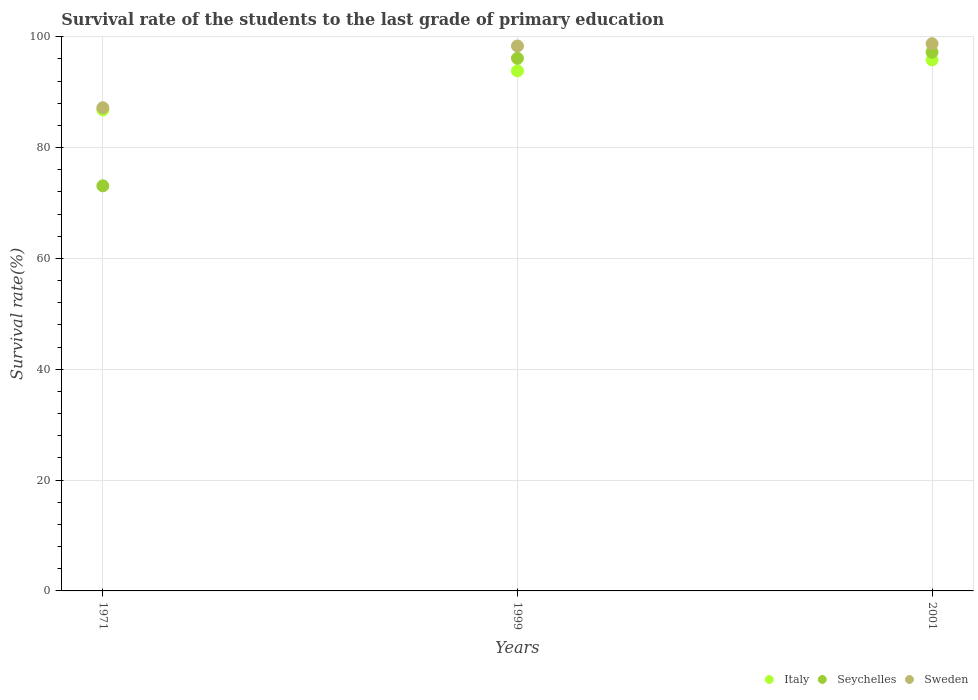What is the survival rate of the students in Italy in 1999?
Make the answer very short. 93.85. Across all years, what is the maximum survival rate of the students in Seychelles?
Make the answer very short. 97.21. Across all years, what is the minimum survival rate of the students in Seychelles?
Ensure brevity in your answer.  73.1. In which year was the survival rate of the students in Italy maximum?
Your response must be concise. 2001. In which year was the survival rate of the students in Seychelles minimum?
Make the answer very short. 1971. What is the total survival rate of the students in Seychelles in the graph?
Your answer should be very brief. 266.41. What is the difference between the survival rate of the students in Italy in 1971 and that in 1999?
Your answer should be compact. -7.06. What is the difference between the survival rate of the students in Italy in 1971 and the survival rate of the students in Seychelles in 1999?
Your answer should be compact. -9.32. What is the average survival rate of the students in Italy per year?
Provide a succinct answer. 92.15. In the year 1999, what is the difference between the survival rate of the students in Seychelles and survival rate of the students in Sweden?
Give a very brief answer. -2.23. In how many years, is the survival rate of the students in Sweden greater than 8 %?
Provide a succinct answer. 3. What is the ratio of the survival rate of the students in Sweden in 1971 to that in 1999?
Offer a terse response. 0.89. Is the survival rate of the students in Sweden in 1999 less than that in 2001?
Provide a succinct answer. Yes. What is the difference between the highest and the second highest survival rate of the students in Italy?
Your answer should be compact. 1.97. What is the difference between the highest and the lowest survival rate of the students in Sweden?
Ensure brevity in your answer.  11.56. In how many years, is the survival rate of the students in Italy greater than the average survival rate of the students in Italy taken over all years?
Provide a succinct answer. 2. Is the survival rate of the students in Sweden strictly greater than the survival rate of the students in Seychelles over the years?
Your answer should be very brief. Yes. Is the survival rate of the students in Italy strictly less than the survival rate of the students in Sweden over the years?
Provide a succinct answer. Yes. How many dotlines are there?
Offer a very short reply. 3. What is the difference between two consecutive major ticks on the Y-axis?
Your answer should be very brief. 20. How are the legend labels stacked?
Provide a short and direct response. Horizontal. What is the title of the graph?
Ensure brevity in your answer.  Survival rate of the students to the last grade of primary education. Does "Burundi" appear as one of the legend labels in the graph?
Your answer should be very brief. No. What is the label or title of the X-axis?
Provide a succinct answer. Years. What is the label or title of the Y-axis?
Your answer should be compact. Survival rate(%). What is the Survival rate(%) in Italy in 1971?
Make the answer very short. 86.79. What is the Survival rate(%) in Seychelles in 1971?
Give a very brief answer. 73.1. What is the Survival rate(%) in Sweden in 1971?
Make the answer very short. 87.19. What is the Survival rate(%) of Italy in 1999?
Keep it short and to the point. 93.85. What is the Survival rate(%) in Seychelles in 1999?
Your answer should be compact. 96.1. What is the Survival rate(%) of Sweden in 1999?
Your response must be concise. 98.33. What is the Survival rate(%) of Italy in 2001?
Your answer should be very brief. 95.82. What is the Survival rate(%) of Seychelles in 2001?
Your answer should be compact. 97.21. What is the Survival rate(%) in Sweden in 2001?
Offer a very short reply. 98.75. Across all years, what is the maximum Survival rate(%) of Italy?
Ensure brevity in your answer.  95.82. Across all years, what is the maximum Survival rate(%) of Seychelles?
Give a very brief answer. 97.21. Across all years, what is the maximum Survival rate(%) of Sweden?
Make the answer very short. 98.75. Across all years, what is the minimum Survival rate(%) in Italy?
Ensure brevity in your answer.  86.79. Across all years, what is the minimum Survival rate(%) in Seychelles?
Your response must be concise. 73.1. Across all years, what is the minimum Survival rate(%) in Sweden?
Your response must be concise. 87.19. What is the total Survival rate(%) of Italy in the graph?
Your answer should be very brief. 276.45. What is the total Survival rate(%) of Seychelles in the graph?
Give a very brief answer. 266.41. What is the total Survival rate(%) of Sweden in the graph?
Offer a very short reply. 284.26. What is the difference between the Survival rate(%) in Italy in 1971 and that in 1999?
Ensure brevity in your answer.  -7.06. What is the difference between the Survival rate(%) in Seychelles in 1971 and that in 1999?
Ensure brevity in your answer.  -23. What is the difference between the Survival rate(%) of Sweden in 1971 and that in 1999?
Make the answer very short. -11.14. What is the difference between the Survival rate(%) of Italy in 1971 and that in 2001?
Keep it short and to the point. -9.03. What is the difference between the Survival rate(%) of Seychelles in 1971 and that in 2001?
Give a very brief answer. -24.11. What is the difference between the Survival rate(%) of Sweden in 1971 and that in 2001?
Ensure brevity in your answer.  -11.56. What is the difference between the Survival rate(%) of Italy in 1999 and that in 2001?
Ensure brevity in your answer.  -1.97. What is the difference between the Survival rate(%) of Seychelles in 1999 and that in 2001?
Offer a terse response. -1.1. What is the difference between the Survival rate(%) in Sweden in 1999 and that in 2001?
Your answer should be compact. -0.42. What is the difference between the Survival rate(%) in Italy in 1971 and the Survival rate(%) in Seychelles in 1999?
Your answer should be compact. -9.32. What is the difference between the Survival rate(%) of Italy in 1971 and the Survival rate(%) of Sweden in 1999?
Your answer should be very brief. -11.54. What is the difference between the Survival rate(%) of Seychelles in 1971 and the Survival rate(%) of Sweden in 1999?
Provide a succinct answer. -25.23. What is the difference between the Survival rate(%) in Italy in 1971 and the Survival rate(%) in Seychelles in 2001?
Your answer should be compact. -10.42. What is the difference between the Survival rate(%) of Italy in 1971 and the Survival rate(%) of Sweden in 2001?
Make the answer very short. -11.96. What is the difference between the Survival rate(%) of Seychelles in 1971 and the Survival rate(%) of Sweden in 2001?
Make the answer very short. -25.65. What is the difference between the Survival rate(%) of Italy in 1999 and the Survival rate(%) of Seychelles in 2001?
Your answer should be very brief. -3.36. What is the difference between the Survival rate(%) in Italy in 1999 and the Survival rate(%) in Sweden in 2001?
Your response must be concise. -4.9. What is the difference between the Survival rate(%) in Seychelles in 1999 and the Survival rate(%) in Sweden in 2001?
Provide a succinct answer. -2.64. What is the average Survival rate(%) in Italy per year?
Keep it short and to the point. 92.15. What is the average Survival rate(%) in Seychelles per year?
Provide a short and direct response. 88.8. What is the average Survival rate(%) of Sweden per year?
Provide a short and direct response. 94.75. In the year 1971, what is the difference between the Survival rate(%) of Italy and Survival rate(%) of Seychelles?
Your answer should be compact. 13.69. In the year 1971, what is the difference between the Survival rate(%) of Italy and Survival rate(%) of Sweden?
Your answer should be compact. -0.4. In the year 1971, what is the difference between the Survival rate(%) of Seychelles and Survival rate(%) of Sweden?
Your answer should be compact. -14.09. In the year 1999, what is the difference between the Survival rate(%) in Italy and Survival rate(%) in Seychelles?
Your answer should be very brief. -2.26. In the year 1999, what is the difference between the Survival rate(%) of Italy and Survival rate(%) of Sweden?
Give a very brief answer. -4.48. In the year 1999, what is the difference between the Survival rate(%) in Seychelles and Survival rate(%) in Sweden?
Offer a terse response. -2.23. In the year 2001, what is the difference between the Survival rate(%) in Italy and Survival rate(%) in Seychelles?
Provide a succinct answer. -1.39. In the year 2001, what is the difference between the Survival rate(%) of Italy and Survival rate(%) of Sweden?
Your answer should be compact. -2.93. In the year 2001, what is the difference between the Survival rate(%) of Seychelles and Survival rate(%) of Sweden?
Offer a very short reply. -1.54. What is the ratio of the Survival rate(%) of Italy in 1971 to that in 1999?
Give a very brief answer. 0.92. What is the ratio of the Survival rate(%) in Seychelles in 1971 to that in 1999?
Give a very brief answer. 0.76. What is the ratio of the Survival rate(%) of Sweden in 1971 to that in 1999?
Give a very brief answer. 0.89. What is the ratio of the Survival rate(%) in Italy in 1971 to that in 2001?
Ensure brevity in your answer.  0.91. What is the ratio of the Survival rate(%) of Seychelles in 1971 to that in 2001?
Offer a terse response. 0.75. What is the ratio of the Survival rate(%) of Sweden in 1971 to that in 2001?
Offer a terse response. 0.88. What is the ratio of the Survival rate(%) in Italy in 1999 to that in 2001?
Offer a terse response. 0.98. What is the ratio of the Survival rate(%) of Seychelles in 1999 to that in 2001?
Your answer should be very brief. 0.99. What is the difference between the highest and the second highest Survival rate(%) in Italy?
Provide a short and direct response. 1.97. What is the difference between the highest and the second highest Survival rate(%) of Seychelles?
Give a very brief answer. 1.1. What is the difference between the highest and the second highest Survival rate(%) of Sweden?
Ensure brevity in your answer.  0.42. What is the difference between the highest and the lowest Survival rate(%) of Italy?
Your answer should be compact. 9.03. What is the difference between the highest and the lowest Survival rate(%) in Seychelles?
Your response must be concise. 24.11. What is the difference between the highest and the lowest Survival rate(%) in Sweden?
Provide a succinct answer. 11.56. 